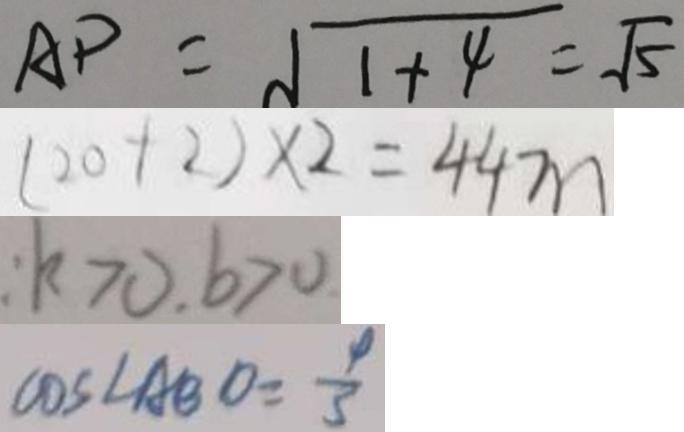<formula> <loc_0><loc_0><loc_500><loc_500>A P = \sqrt { 1 + 4 } = \sqrt { 5 } 
 ( 2 0 + 2 ) \times 2 = 4 4 m 
 : k > 0 , b > 0 
 \cos \angle A B O = \frac { 4 } { 3 }</formula> 